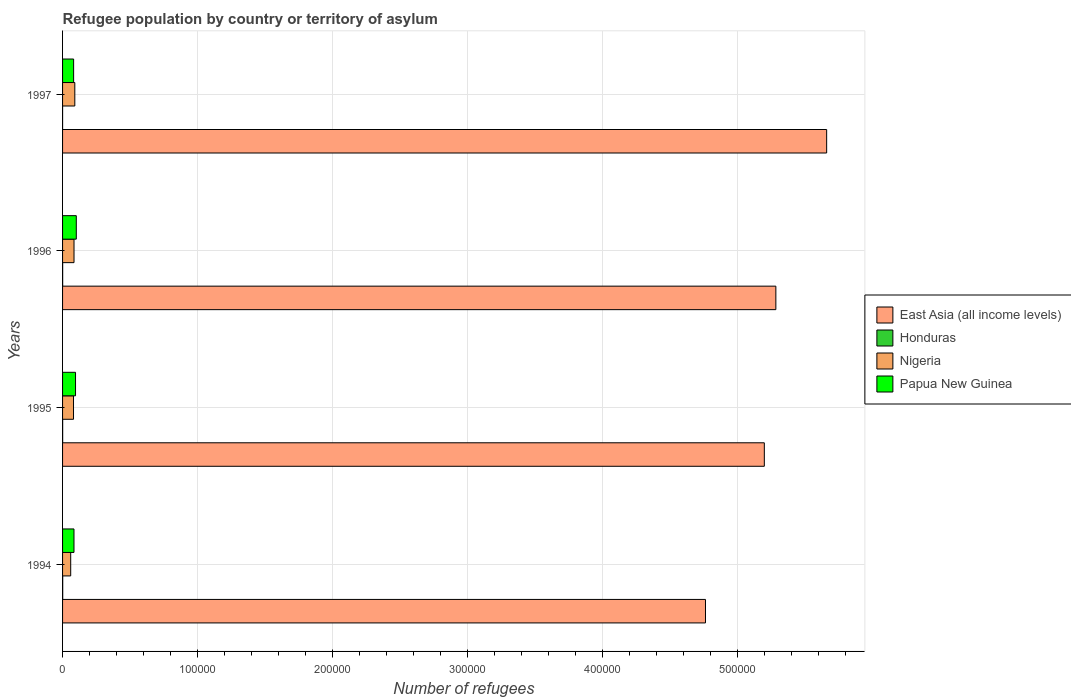How many different coloured bars are there?
Your answer should be compact. 4. How many groups of bars are there?
Offer a very short reply. 4. Are the number of bars per tick equal to the number of legend labels?
Offer a very short reply. Yes. How many bars are there on the 4th tick from the bottom?
Give a very brief answer. 4. What is the number of refugees in East Asia (all income levels) in 1997?
Keep it short and to the point. 5.66e+05. Across all years, what is the maximum number of refugees in Papua New Guinea?
Provide a succinct answer. 1.02e+04. Across all years, what is the minimum number of refugees in Nigeria?
Your answer should be compact. 6026. What is the total number of refugees in Papua New Guinea in the graph?
Keep it short and to the point. 3.64e+04. What is the difference between the number of refugees in Papua New Guinea in 1996 and that in 1997?
Provide a succinct answer. 1978. What is the difference between the number of refugees in Honduras in 1996 and the number of refugees in East Asia (all income levels) in 1995?
Give a very brief answer. -5.20e+05. What is the average number of refugees in East Asia (all income levels) per year?
Make the answer very short. 5.23e+05. In the year 1995, what is the difference between the number of refugees in Nigeria and number of refugees in Honduras?
Make the answer very short. 8055. In how many years, is the number of refugees in Papua New Guinea greater than 340000 ?
Offer a terse response. 0. What is the ratio of the number of refugees in Nigeria in 1996 to that in 1997?
Your answer should be compact. 0.94. Is the number of refugees in East Asia (all income levels) in 1994 less than that in 1997?
Provide a short and direct response. Yes. Is the difference between the number of refugees in Nigeria in 1995 and 1997 greater than the difference between the number of refugees in Honduras in 1995 and 1997?
Provide a succinct answer. No. What is the difference between the highest and the second highest number of refugees in Papua New Guinea?
Provide a succinct answer. 575. What is the difference between the highest and the lowest number of refugees in East Asia (all income levels)?
Provide a short and direct response. 8.98e+04. Is it the case that in every year, the sum of the number of refugees in Honduras and number of refugees in East Asia (all income levels) is greater than the sum of number of refugees in Papua New Guinea and number of refugees in Nigeria?
Ensure brevity in your answer.  Yes. What does the 1st bar from the top in 1994 represents?
Keep it short and to the point. Papua New Guinea. What does the 4th bar from the bottom in 1996 represents?
Your answer should be compact. Papua New Guinea. How many bars are there?
Offer a terse response. 16. What is the difference between two consecutive major ticks on the X-axis?
Offer a very short reply. 1.00e+05. Does the graph contain any zero values?
Make the answer very short. No. Where does the legend appear in the graph?
Provide a succinct answer. Center right. What is the title of the graph?
Provide a succinct answer. Refugee population by country or territory of asylum. What is the label or title of the X-axis?
Make the answer very short. Number of refugees. What is the label or title of the Y-axis?
Your response must be concise. Years. What is the Number of refugees of East Asia (all income levels) in 1994?
Provide a short and direct response. 4.76e+05. What is the Number of refugees of Honduras in 1994?
Offer a very short reply. 104. What is the Number of refugees of Nigeria in 1994?
Your response must be concise. 6026. What is the Number of refugees of Papua New Guinea in 1994?
Provide a short and direct response. 8461. What is the Number of refugees of East Asia (all income levels) in 1995?
Provide a succinct answer. 5.20e+05. What is the Number of refugees in Honduras in 1995?
Your response must be concise. 63. What is the Number of refugees in Nigeria in 1995?
Offer a terse response. 8118. What is the Number of refugees of Papua New Guinea in 1995?
Provide a succinct answer. 9601. What is the Number of refugees in East Asia (all income levels) in 1996?
Provide a succinct answer. 5.28e+05. What is the Number of refugees of Nigeria in 1996?
Offer a terse response. 8486. What is the Number of refugees in Papua New Guinea in 1996?
Provide a short and direct response. 1.02e+04. What is the Number of refugees in East Asia (all income levels) in 1997?
Offer a terse response. 5.66e+05. What is the Number of refugees in Nigeria in 1997?
Your answer should be very brief. 9071. What is the Number of refugees of Papua New Guinea in 1997?
Your answer should be very brief. 8198. Across all years, what is the maximum Number of refugees of East Asia (all income levels)?
Make the answer very short. 5.66e+05. Across all years, what is the maximum Number of refugees in Honduras?
Your answer should be very brief. 104. Across all years, what is the maximum Number of refugees of Nigeria?
Your answer should be compact. 9071. Across all years, what is the maximum Number of refugees of Papua New Guinea?
Your answer should be very brief. 1.02e+04. Across all years, what is the minimum Number of refugees of East Asia (all income levels)?
Keep it short and to the point. 4.76e+05. Across all years, what is the minimum Number of refugees in Nigeria?
Provide a succinct answer. 6026. Across all years, what is the minimum Number of refugees in Papua New Guinea?
Provide a short and direct response. 8198. What is the total Number of refugees of East Asia (all income levels) in the graph?
Provide a short and direct response. 2.09e+06. What is the total Number of refugees in Honduras in the graph?
Give a very brief answer. 239. What is the total Number of refugees in Nigeria in the graph?
Your response must be concise. 3.17e+04. What is the total Number of refugees of Papua New Guinea in the graph?
Your answer should be very brief. 3.64e+04. What is the difference between the Number of refugees of East Asia (all income levels) in 1994 and that in 1995?
Keep it short and to the point. -4.36e+04. What is the difference between the Number of refugees in Honduras in 1994 and that in 1995?
Give a very brief answer. 41. What is the difference between the Number of refugees in Nigeria in 1994 and that in 1995?
Provide a succinct answer. -2092. What is the difference between the Number of refugees of Papua New Guinea in 1994 and that in 1995?
Keep it short and to the point. -1140. What is the difference between the Number of refugees of East Asia (all income levels) in 1994 and that in 1996?
Provide a short and direct response. -5.21e+04. What is the difference between the Number of refugees in Honduras in 1994 and that in 1996?
Keep it short and to the point. 41. What is the difference between the Number of refugees in Nigeria in 1994 and that in 1996?
Give a very brief answer. -2460. What is the difference between the Number of refugees in Papua New Guinea in 1994 and that in 1996?
Your answer should be very brief. -1715. What is the difference between the Number of refugees of East Asia (all income levels) in 1994 and that in 1997?
Provide a succinct answer. -8.98e+04. What is the difference between the Number of refugees in Honduras in 1994 and that in 1997?
Keep it short and to the point. 95. What is the difference between the Number of refugees in Nigeria in 1994 and that in 1997?
Your answer should be compact. -3045. What is the difference between the Number of refugees in Papua New Guinea in 1994 and that in 1997?
Offer a very short reply. 263. What is the difference between the Number of refugees of East Asia (all income levels) in 1995 and that in 1996?
Offer a very short reply. -8544. What is the difference between the Number of refugees of Honduras in 1995 and that in 1996?
Ensure brevity in your answer.  0. What is the difference between the Number of refugees in Nigeria in 1995 and that in 1996?
Offer a terse response. -368. What is the difference between the Number of refugees of Papua New Guinea in 1995 and that in 1996?
Your answer should be very brief. -575. What is the difference between the Number of refugees in East Asia (all income levels) in 1995 and that in 1997?
Provide a succinct answer. -4.62e+04. What is the difference between the Number of refugees of Honduras in 1995 and that in 1997?
Your answer should be compact. 54. What is the difference between the Number of refugees of Nigeria in 1995 and that in 1997?
Keep it short and to the point. -953. What is the difference between the Number of refugees in Papua New Guinea in 1995 and that in 1997?
Offer a very short reply. 1403. What is the difference between the Number of refugees in East Asia (all income levels) in 1996 and that in 1997?
Your answer should be compact. -3.76e+04. What is the difference between the Number of refugees in Honduras in 1996 and that in 1997?
Provide a succinct answer. 54. What is the difference between the Number of refugees of Nigeria in 1996 and that in 1997?
Give a very brief answer. -585. What is the difference between the Number of refugees in Papua New Guinea in 1996 and that in 1997?
Ensure brevity in your answer.  1978. What is the difference between the Number of refugees of East Asia (all income levels) in 1994 and the Number of refugees of Honduras in 1995?
Provide a succinct answer. 4.76e+05. What is the difference between the Number of refugees of East Asia (all income levels) in 1994 and the Number of refugees of Nigeria in 1995?
Keep it short and to the point. 4.68e+05. What is the difference between the Number of refugees in East Asia (all income levels) in 1994 and the Number of refugees in Papua New Guinea in 1995?
Offer a very short reply. 4.67e+05. What is the difference between the Number of refugees of Honduras in 1994 and the Number of refugees of Nigeria in 1995?
Ensure brevity in your answer.  -8014. What is the difference between the Number of refugees of Honduras in 1994 and the Number of refugees of Papua New Guinea in 1995?
Your answer should be very brief. -9497. What is the difference between the Number of refugees of Nigeria in 1994 and the Number of refugees of Papua New Guinea in 1995?
Ensure brevity in your answer.  -3575. What is the difference between the Number of refugees of East Asia (all income levels) in 1994 and the Number of refugees of Honduras in 1996?
Your answer should be very brief. 4.76e+05. What is the difference between the Number of refugees in East Asia (all income levels) in 1994 and the Number of refugees in Nigeria in 1996?
Provide a short and direct response. 4.68e+05. What is the difference between the Number of refugees of East Asia (all income levels) in 1994 and the Number of refugees of Papua New Guinea in 1996?
Your answer should be compact. 4.66e+05. What is the difference between the Number of refugees of Honduras in 1994 and the Number of refugees of Nigeria in 1996?
Ensure brevity in your answer.  -8382. What is the difference between the Number of refugees in Honduras in 1994 and the Number of refugees in Papua New Guinea in 1996?
Give a very brief answer. -1.01e+04. What is the difference between the Number of refugees of Nigeria in 1994 and the Number of refugees of Papua New Guinea in 1996?
Your answer should be compact. -4150. What is the difference between the Number of refugees of East Asia (all income levels) in 1994 and the Number of refugees of Honduras in 1997?
Keep it short and to the point. 4.76e+05. What is the difference between the Number of refugees of East Asia (all income levels) in 1994 and the Number of refugees of Nigeria in 1997?
Your response must be concise. 4.67e+05. What is the difference between the Number of refugees in East Asia (all income levels) in 1994 and the Number of refugees in Papua New Guinea in 1997?
Keep it short and to the point. 4.68e+05. What is the difference between the Number of refugees of Honduras in 1994 and the Number of refugees of Nigeria in 1997?
Your answer should be compact. -8967. What is the difference between the Number of refugees of Honduras in 1994 and the Number of refugees of Papua New Guinea in 1997?
Your answer should be very brief. -8094. What is the difference between the Number of refugees of Nigeria in 1994 and the Number of refugees of Papua New Guinea in 1997?
Ensure brevity in your answer.  -2172. What is the difference between the Number of refugees in East Asia (all income levels) in 1995 and the Number of refugees in Honduras in 1996?
Ensure brevity in your answer.  5.20e+05. What is the difference between the Number of refugees of East Asia (all income levels) in 1995 and the Number of refugees of Nigeria in 1996?
Keep it short and to the point. 5.11e+05. What is the difference between the Number of refugees in East Asia (all income levels) in 1995 and the Number of refugees in Papua New Guinea in 1996?
Provide a short and direct response. 5.10e+05. What is the difference between the Number of refugees in Honduras in 1995 and the Number of refugees in Nigeria in 1996?
Provide a short and direct response. -8423. What is the difference between the Number of refugees of Honduras in 1995 and the Number of refugees of Papua New Guinea in 1996?
Give a very brief answer. -1.01e+04. What is the difference between the Number of refugees of Nigeria in 1995 and the Number of refugees of Papua New Guinea in 1996?
Your answer should be compact. -2058. What is the difference between the Number of refugees of East Asia (all income levels) in 1995 and the Number of refugees of Honduras in 1997?
Make the answer very short. 5.20e+05. What is the difference between the Number of refugees in East Asia (all income levels) in 1995 and the Number of refugees in Nigeria in 1997?
Your answer should be very brief. 5.11e+05. What is the difference between the Number of refugees in East Asia (all income levels) in 1995 and the Number of refugees in Papua New Guinea in 1997?
Your answer should be very brief. 5.12e+05. What is the difference between the Number of refugees of Honduras in 1995 and the Number of refugees of Nigeria in 1997?
Make the answer very short. -9008. What is the difference between the Number of refugees in Honduras in 1995 and the Number of refugees in Papua New Guinea in 1997?
Offer a very short reply. -8135. What is the difference between the Number of refugees of Nigeria in 1995 and the Number of refugees of Papua New Guinea in 1997?
Provide a succinct answer. -80. What is the difference between the Number of refugees in East Asia (all income levels) in 1996 and the Number of refugees in Honduras in 1997?
Your response must be concise. 5.28e+05. What is the difference between the Number of refugees of East Asia (all income levels) in 1996 and the Number of refugees of Nigeria in 1997?
Make the answer very short. 5.19e+05. What is the difference between the Number of refugees in East Asia (all income levels) in 1996 and the Number of refugees in Papua New Guinea in 1997?
Keep it short and to the point. 5.20e+05. What is the difference between the Number of refugees of Honduras in 1996 and the Number of refugees of Nigeria in 1997?
Ensure brevity in your answer.  -9008. What is the difference between the Number of refugees in Honduras in 1996 and the Number of refugees in Papua New Guinea in 1997?
Offer a very short reply. -8135. What is the difference between the Number of refugees of Nigeria in 1996 and the Number of refugees of Papua New Guinea in 1997?
Provide a succinct answer. 288. What is the average Number of refugees of East Asia (all income levels) per year?
Provide a succinct answer. 5.23e+05. What is the average Number of refugees of Honduras per year?
Ensure brevity in your answer.  59.75. What is the average Number of refugees in Nigeria per year?
Your response must be concise. 7925.25. What is the average Number of refugees of Papua New Guinea per year?
Keep it short and to the point. 9109. In the year 1994, what is the difference between the Number of refugees in East Asia (all income levels) and Number of refugees in Honduras?
Offer a very short reply. 4.76e+05. In the year 1994, what is the difference between the Number of refugees in East Asia (all income levels) and Number of refugees in Nigeria?
Your answer should be compact. 4.70e+05. In the year 1994, what is the difference between the Number of refugees in East Asia (all income levels) and Number of refugees in Papua New Guinea?
Offer a terse response. 4.68e+05. In the year 1994, what is the difference between the Number of refugees in Honduras and Number of refugees in Nigeria?
Provide a succinct answer. -5922. In the year 1994, what is the difference between the Number of refugees in Honduras and Number of refugees in Papua New Guinea?
Your response must be concise. -8357. In the year 1994, what is the difference between the Number of refugees of Nigeria and Number of refugees of Papua New Guinea?
Provide a short and direct response. -2435. In the year 1995, what is the difference between the Number of refugees in East Asia (all income levels) and Number of refugees in Honduras?
Your answer should be compact. 5.20e+05. In the year 1995, what is the difference between the Number of refugees of East Asia (all income levels) and Number of refugees of Nigeria?
Ensure brevity in your answer.  5.12e+05. In the year 1995, what is the difference between the Number of refugees of East Asia (all income levels) and Number of refugees of Papua New Guinea?
Offer a terse response. 5.10e+05. In the year 1995, what is the difference between the Number of refugees in Honduras and Number of refugees in Nigeria?
Offer a terse response. -8055. In the year 1995, what is the difference between the Number of refugees in Honduras and Number of refugees in Papua New Guinea?
Your answer should be compact. -9538. In the year 1995, what is the difference between the Number of refugees in Nigeria and Number of refugees in Papua New Guinea?
Your answer should be compact. -1483. In the year 1996, what is the difference between the Number of refugees of East Asia (all income levels) and Number of refugees of Honduras?
Your answer should be very brief. 5.28e+05. In the year 1996, what is the difference between the Number of refugees in East Asia (all income levels) and Number of refugees in Nigeria?
Your response must be concise. 5.20e+05. In the year 1996, what is the difference between the Number of refugees in East Asia (all income levels) and Number of refugees in Papua New Guinea?
Your answer should be compact. 5.18e+05. In the year 1996, what is the difference between the Number of refugees in Honduras and Number of refugees in Nigeria?
Keep it short and to the point. -8423. In the year 1996, what is the difference between the Number of refugees in Honduras and Number of refugees in Papua New Guinea?
Make the answer very short. -1.01e+04. In the year 1996, what is the difference between the Number of refugees of Nigeria and Number of refugees of Papua New Guinea?
Your answer should be very brief. -1690. In the year 1997, what is the difference between the Number of refugees of East Asia (all income levels) and Number of refugees of Honduras?
Offer a terse response. 5.66e+05. In the year 1997, what is the difference between the Number of refugees of East Asia (all income levels) and Number of refugees of Nigeria?
Provide a short and direct response. 5.57e+05. In the year 1997, what is the difference between the Number of refugees of East Asia (all income levels) and Number of refugees of Papua New Guinea?
Offer a terse response. 5.58e+05. In the year 1997, what is the difference between the Number of refugees in Honduras and Number of refugees in Nigeria?
Ensure brevity in your answer.  -9062. In the year 1997, what is the difference between the Number of refugees in Honduras and Number of refugees in Papua New Guinea?
Your answer should be compact. -8189. In the year 1997, what is the difference between the Number of refugees in Nigeria and Number of refugees in Papua New Guinea?
Provide a succinct answer. 873. What is the ratio of the Number of refugees in East Asia (all income levels) in 1994 to that in 1995?
Make the answer very short. 0.92. What is the ratio of the Number of refugees in Honduras in 1994 to that in 1995?
Make the answer very short. 1.65. What is the ratio of the Number of refugees in Nigeria in 1994 to that in 1995?
Offer a terse response. 0.74. What is the ratio of the Number of refugees of Papua New Guinea in 1994 to that in 1995?
Make the answer very short. 0.88. What is the ratio of the Number of refugees of East Asia (all income levels) in 1994 to that in 1996?
Make the answer very short. 0.9. What is the ratio of the Number of refugees in Honduras in 1994 to that in 1996?
Offer a terse response. 1.65. What is the ratio of the Number of refugees in Nigeria in 1994 to that in 1996?
Your response must be concise. 0.71. What is the ratio of the Number of refugees of Papua New Guinea in 1994 to that in 1996?
Offer a terse response. 0.83. What is the ratio of the Number of refugees in East Asia (all income levels) in 1994 to that in 1997?
Your answer should be compact. 0.84. What is the ratio of the Number of refugees in Honduras in 1994 to that in 1997?
Provide a short and direct response. 11.56. What is the ratio of the Number of refugees of Nigeria in 1994 to that in 1997?
Offer a very short reply. 0.66. What is the ratio of the Number of refugees in Papua New Guinea in 1994 to that in 1997?
Provide a short and direct response. 1.03. What is the ratio of the Number of refugees of East Asia (all income levels) in 1995 to that in 1996?
Your answer should be very brief. 0.98. What is the ratio of the Number of refugees in Honduras in 1995 to that in 1996?
Make the answer very short. 1. What is the ratio of the Number of refugees in Nigeria in 1995 to that in 1996?
Give a very brief answer. 0.96. What is the ratio of the Number of refugees in Papua New Guinea in 1995 to that in 1996?
Offer a very short reply. 0.94. What is the ratio of the Number of refugees in East Asia (all income levels) in 1995 to that in 1997?
Provide a short and direct response. 0.92. What is the ratio of the Number of refugees in Nigeria in 1995 to that in 1997?
Give a very brief answer. 0.89. What is the ratio of the Number of refugees in Papua New Guinea in 1995 to that in 1997?
Give a very brief answer. 1.17. What is the ratio of the Number of refugees of East Asia (all income levels) in 1996 to that in 1997?
Make the answer very short. 0.93. What is the ratio of the Number of refugees of Nigeria in 1996 to that in 1997?
Your answer should be compact. 0.94. What is the ratio of the Number of refugees in Papua New Guinea in 1996 to that in 1997?
Offer a very short reply. 1.24. What is the difference between the highest and the second highest Number of refugees in East Asia (all income levels)?
Your answer should be compact. 3.76e+04. What is the difference between the highest and the second highest Number of refugees in Nigeria?
Your answer should be very brief. 585. What is the difference between the highest and the second highest Number of refugees of Papua New Guinea?
Your answer should be very brief. 575. What is the difference between the highest and the lowest Number of refugees of East Asia (all income levels)?
Offer a terse response. 8.98e+04. What is the difference between the highest and the lowest Number of refugees of Nigeria?
Provide a succinct answer. 3045. What is the difference between the highest and the lowest Number of refugees of Papua New Guinea?
Your response must be concise. 1978. 